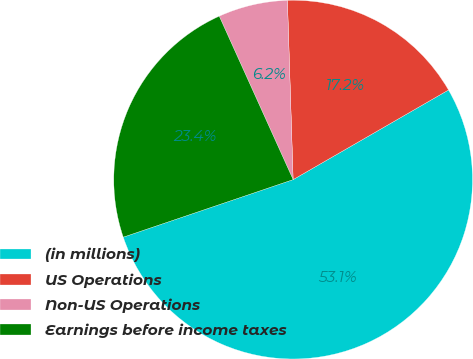Convert chart to OTSL. <chart><loc_0><loc_0><loc_500><loc_500><pie_chart><fcel>(in millions)<fcel>US Operations<fcel>Non-US Operations<fcel>Earnings before income taxes<nl><fcel>53.13%<fcel>17.18%<fcel>6.25%<fcel>23.44%<nl></chart> 